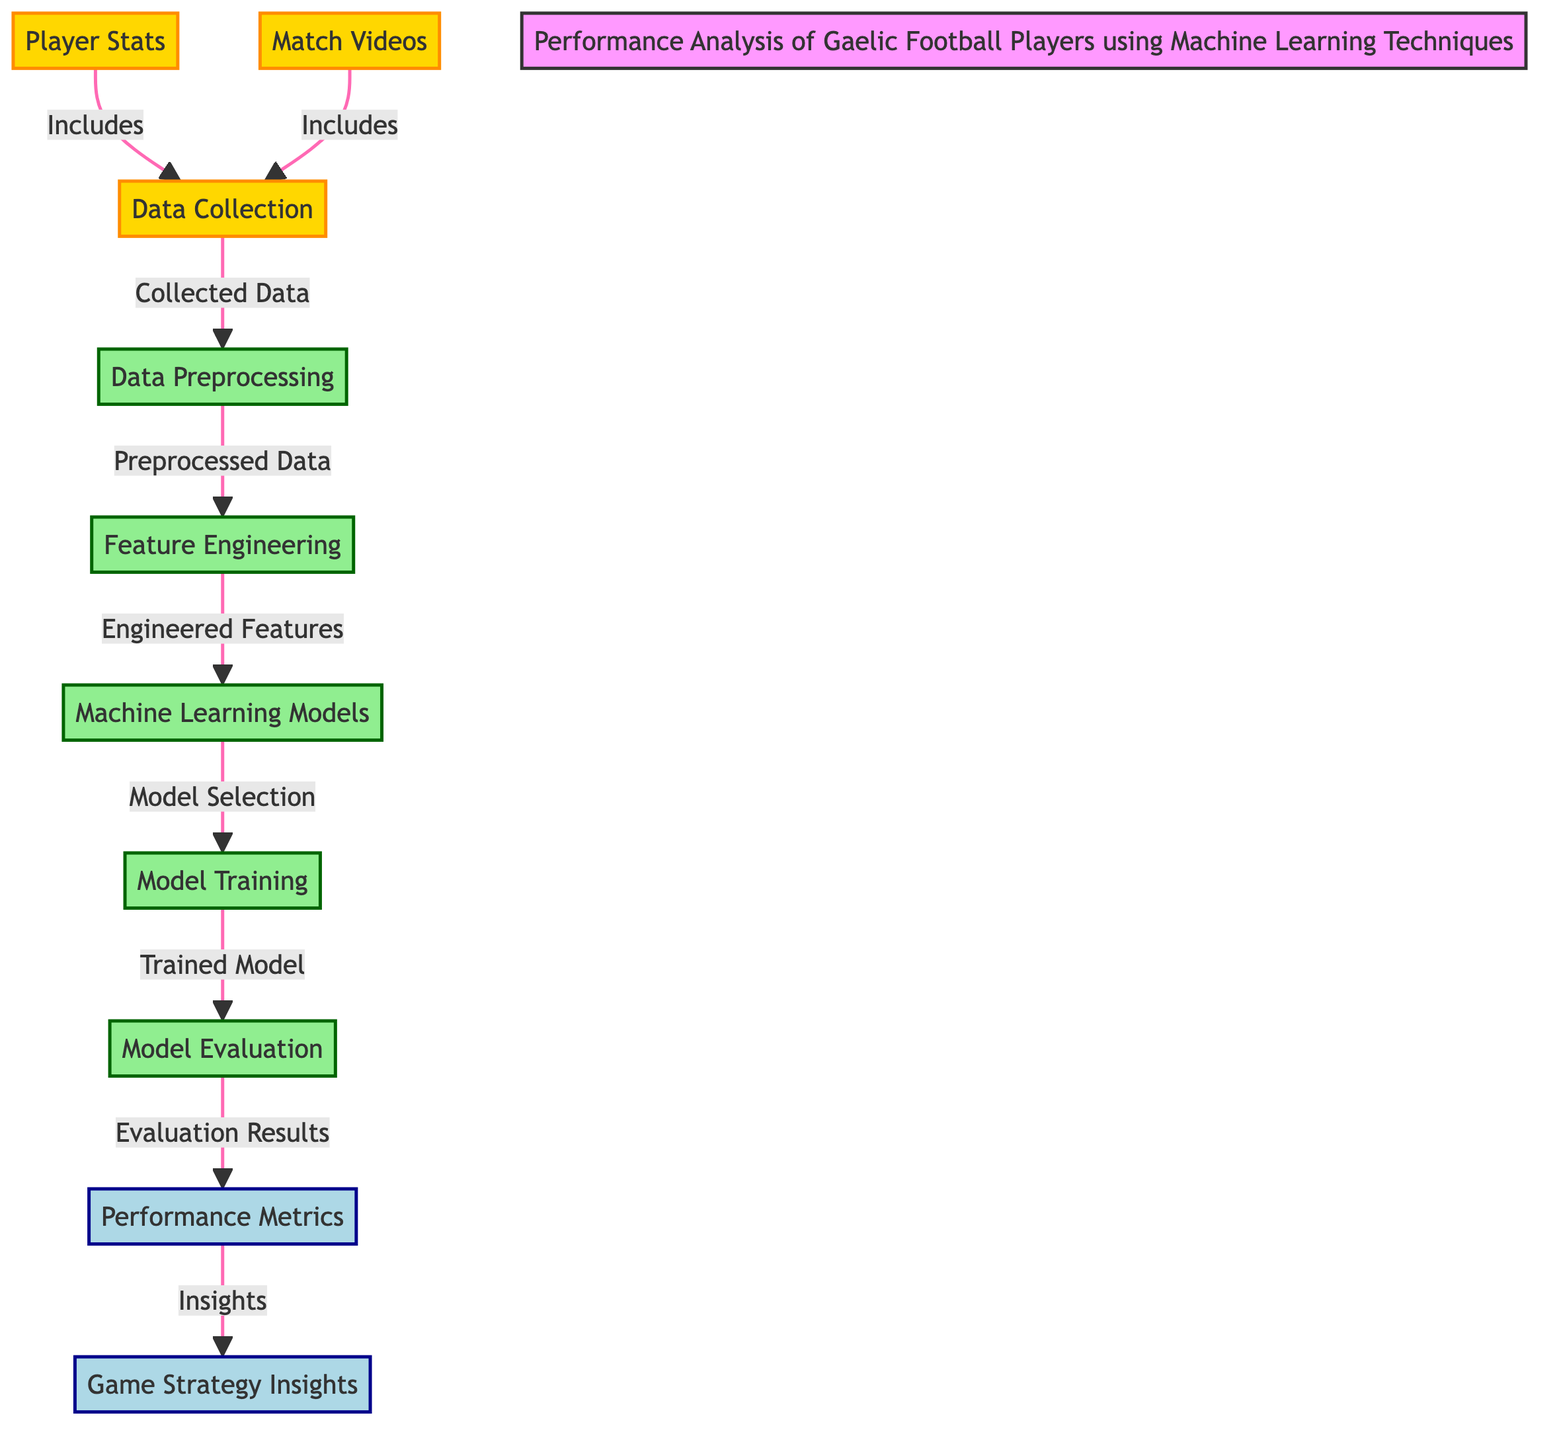What is the first step in the diagram? The first step illustrated in the diagram is "Data Collection," as it is where both player stats and match videos flow into the process.
Answer: Data Collection How many insights are indicated in the diagram? There are two insights indicated at the end of the flowchart: "Performance Metrics" and "Game Strategy Insights."
Answer: Two What follows "Feature Engineering" in the flow? After "Feature Engineering," the next process is "Machine Learning Models," showing a sequential flow in the diagram.
Answer: Machine Learning Models Which type of node is "Model Evaluation"? "Model Evaluation" is classified under process nodes, as it represents a step in the workflow.
Answer: Process What data sources are included in the "Data Collection"? The data sources included in "Data Collection" are "Player Stats" and "Match Videos," which are interconnected to the main node.
Answer: Player Stats and Match Videos How are "Player Stats" related to "Data Collection"? "Player Stats" directly connects to "Data Collection" as an inclusive source that contributes to the overall collected data.
Answer: Inclusive source What type of data transitions from "Data Preprocessing" to "Feature Engineering"? The transition is from "Preprocessed Data" to "Engineered Features," indicating the progression in processing data for analysis.
Answer: Preprocessed Data How many processes are there in total? There are five distinct processes in the diagram, namely "Data Preprocessing," "Feature Engineering," "Machine Learning Models," "Model Training," and "Model Evaluation."
Answer: Five What do the final insights derive from? The final insights of "Performance Metrics" and "Game Strategy Insights" derive from the "Evaluation Results" of "Model Evaluation."
Answer: Evaluation Results 